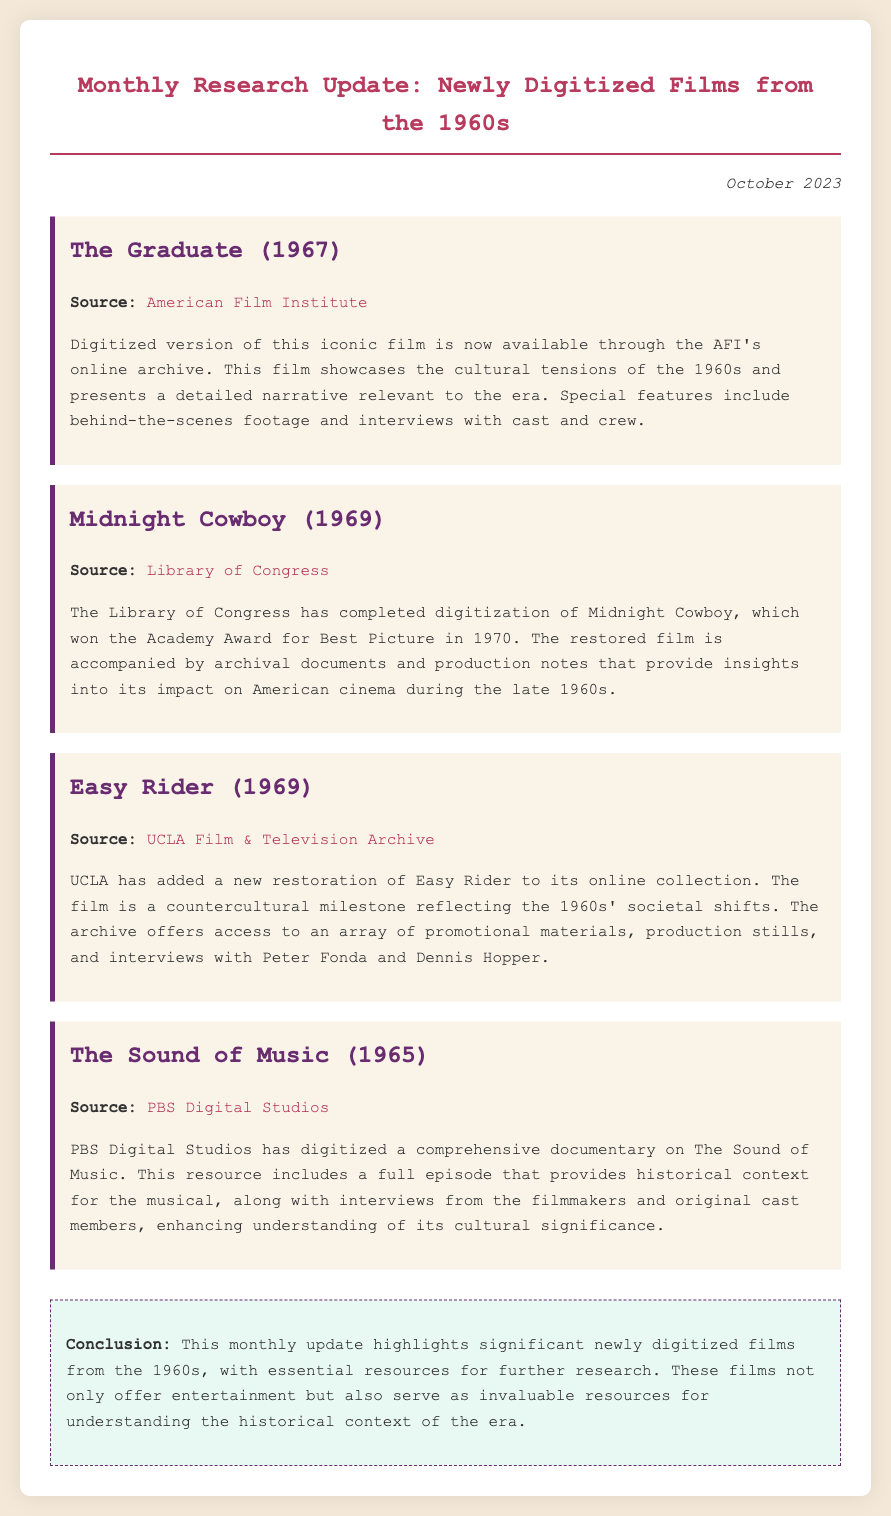What is the title of the film digitized by the American Film Institute? The document lists "The Graduate (1967)" as the film digitized by the American Film Institute.
Answer: The Graduate (1967) Which organization digitized "Midnight Cowboy"? The document states that "Midnight Cowboy" was digitized by the Library of Congress.
Answer: Library of Congress What year was "Easy Rider" released? According to the document, "Easy Rider" was released in 1969.
Answer: 1969 What type of content does PBS Digital Studios provide related to "The Sound of Music"? The document mentions that PBS Digital Studios has digitized a comprehensive documentary, including historical context and interviews related to "The Sound of Music."
Answer: Documentary Which film won the Academy Award for Best Picture in 1970? "Midnight Cowboy," which is mentioned in the document, won the Academy Award for Best Picture in 1970.
Answer: Midnight Cowboy What cultural significance is associated with "Easy Rider"? The document notes that "Easy Rider" is a countercultural milestone reflecting the societal shifts of the 1960s.
Answer: Countercultural milestone What is highlighted in the conclusion of the memo? The conclusion emphasizes significant newly digitized films from the 1960s as resources for understanding the historical context of the era.
Answer: Historical context How many films are mentioned in the document? The document lists four films as newly digitized from the 1960s.
Answer: Four 